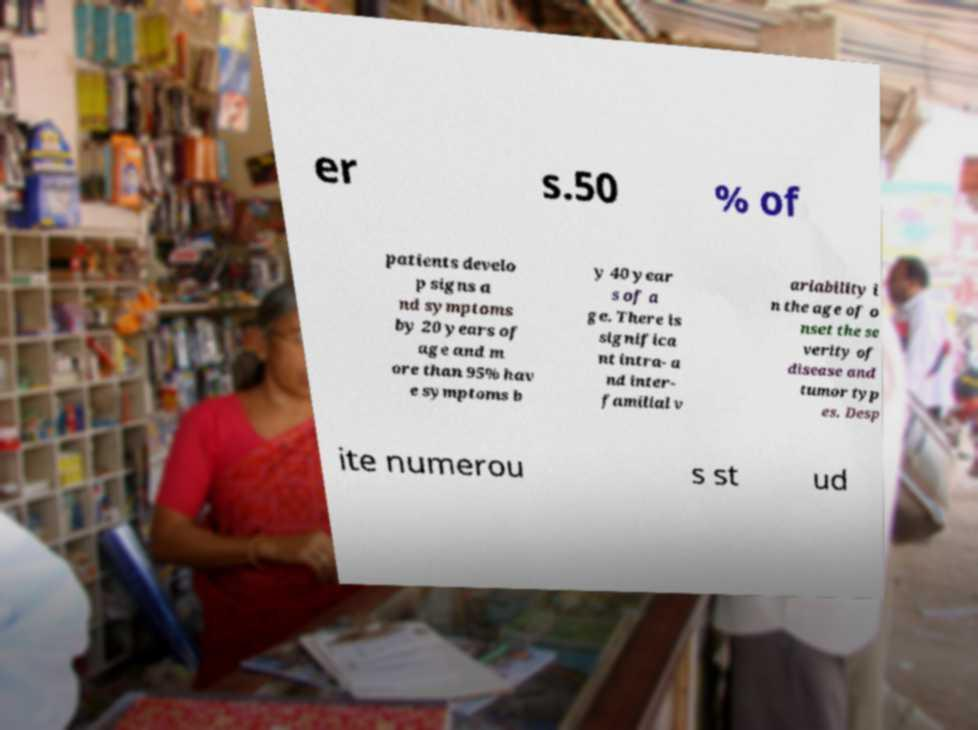Can you read and provide the text displayed in the image?This photo seems to have some interesting text. Can you extract and type it out for me? er s.50 % of patients develo p signs a nd symptoms by 20 years of age and m ore than 95% hav e symptoms b y 40 year s of a ge. There is significa nt intra- a nd inter- familial v ariability i n the age of o nset the se verity of disease and tumor typ es. Desp ite numerou s st ud 